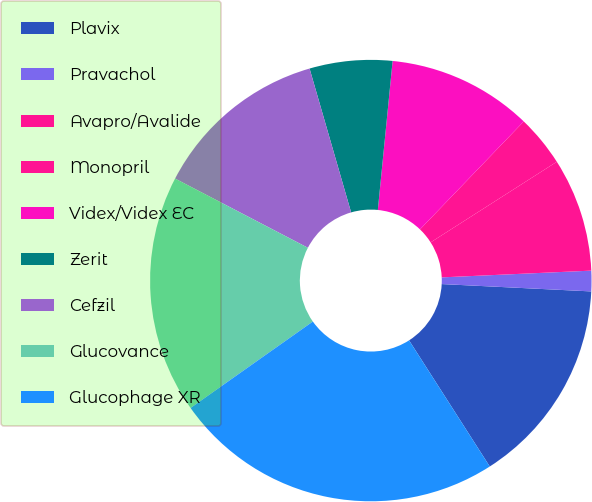<chart> <loc_0><loc_0><loc_500><loc_500><pie_chart><fcel>Plavix<fcel>Pravachol<fcel>Avapro/Avalide<fcel>Monopril<fcel>Videx/Videx EC<fcel>Zerit<fcel>Cefzil<fcel>Glucovance<fcel>Glucophage XR<nl><fcel>15.16%<fcel>1.5%<fcel>8.33%<fcel>3.77%<fcel>10.61%<fcel>6.05%<fcel>12.88%<fcel>17.44%<fcel>24.27%<nl></chart> 